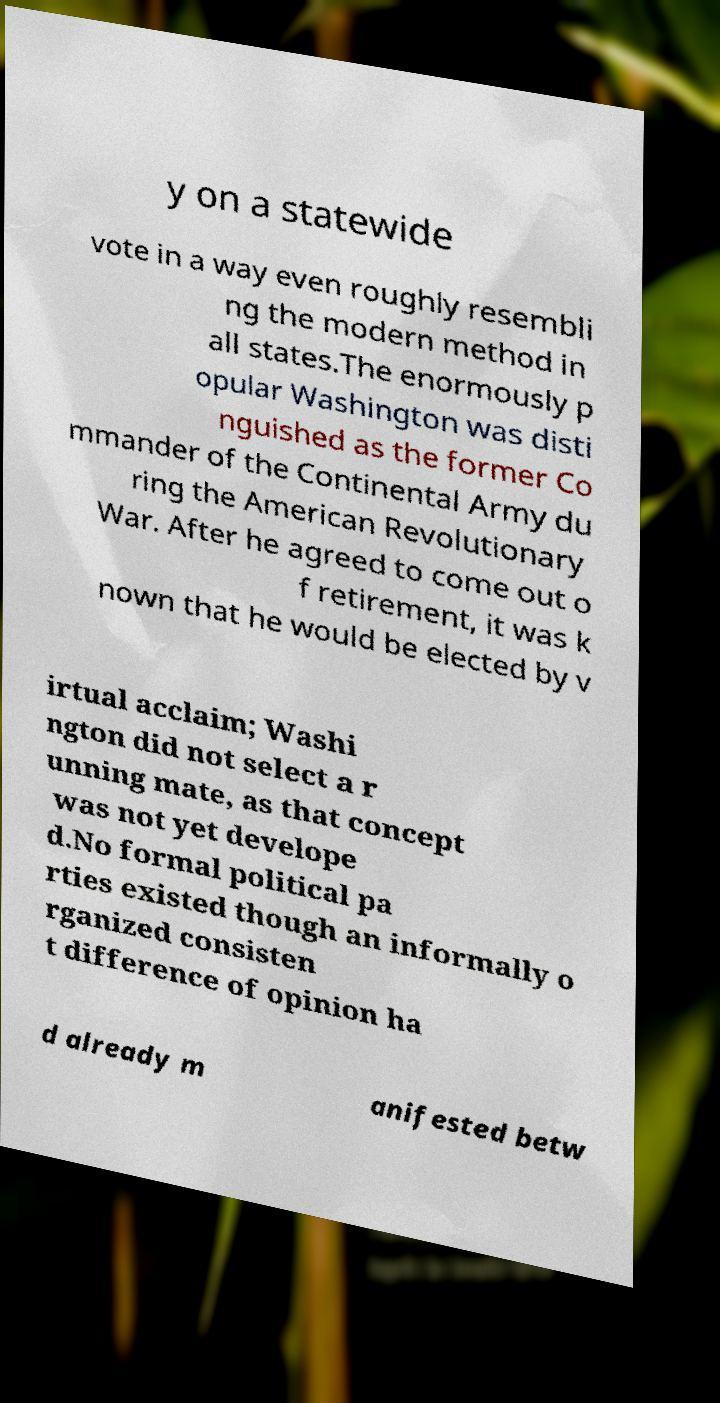Could you assist in decoding the text presented in this image and type it out clearly? y on a statewide vote in a way even roughly resembli ng the modern method in all states.The enormously p opular Washington was disti nguished as the former Co mmander of the Continental Army du ring the American Revolutionary War. After he agreed to come out o f retirement, it was k nown that he would be elected by v irtual acclaim; Washi ngton did not select a r unning mate, as that concept was not yet develope d.No formal political pa rties existed though an informally o rganized consisten t difference of opinion ha d already m anifested betw 